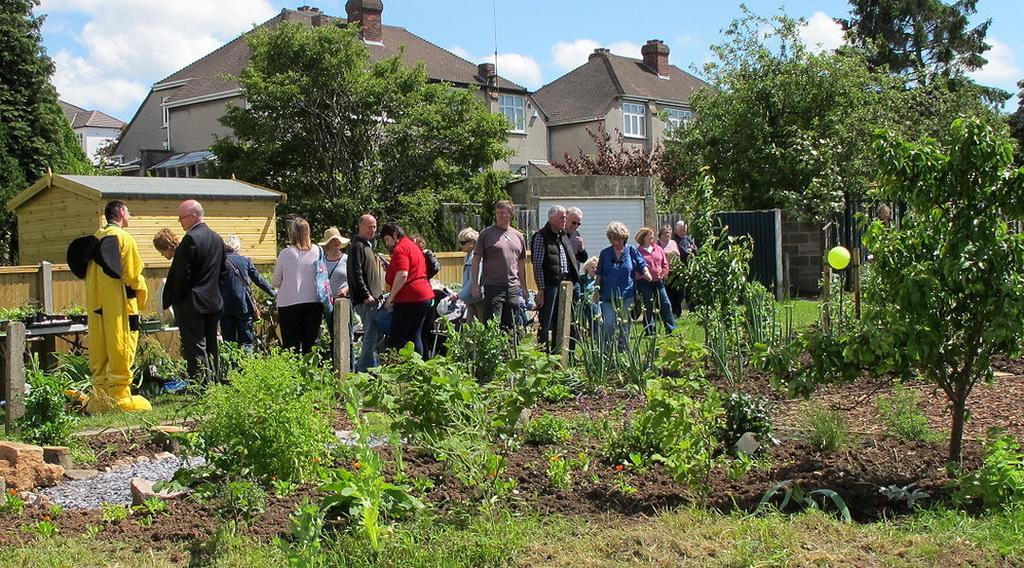How would you summarize this image in a sentence or two? In this image at front there are plants. Behind the plants there are few people standing on the surface of the grass. At the back side there is a table and on top of it there are plants. At the background there are trees, buildings and sky. 